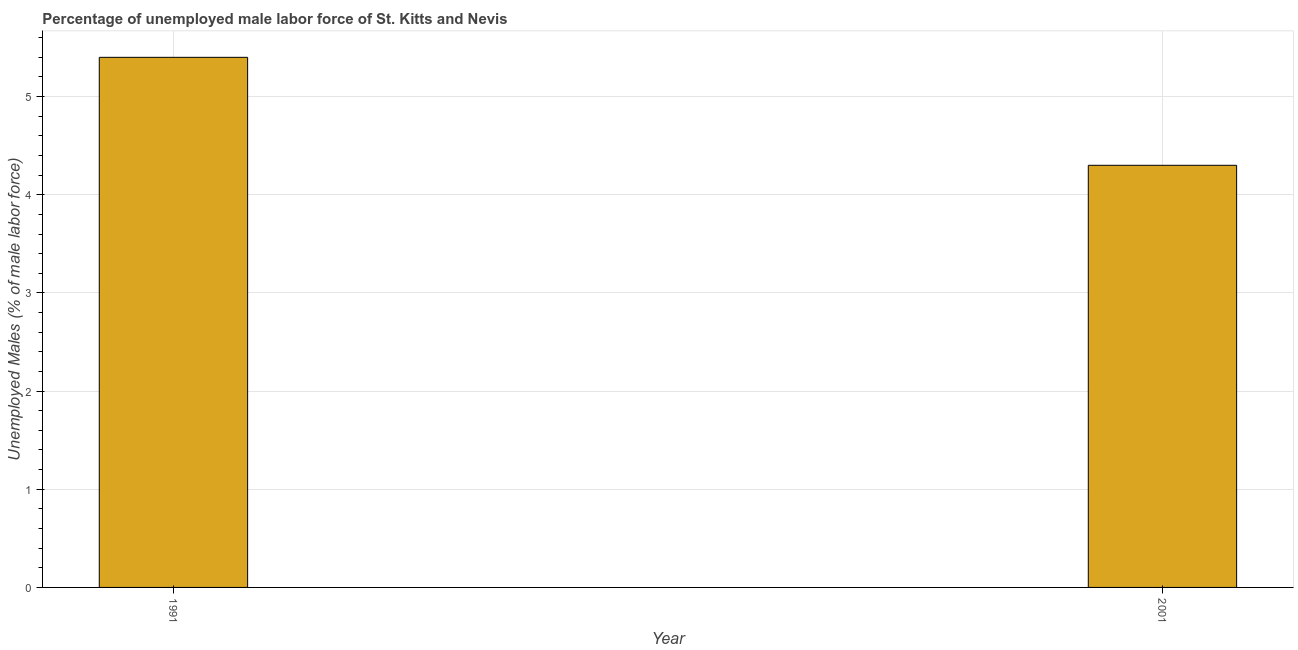Does the graph contain any zero values?
Provide a succinct answer. No. Does the graph contain grids?
Your answer should be very brief. Yes. What is the title of the graph?
Your answer should be compact. Percentage of unemployed male labor force of St. Kitts and Nevis. What is the label or title of the Y-axis?
Your response must be concise. Unemployed Males (% of male labor force). What is the total unemployed male labour force in 2001?
Give a very brief answer. 4.3. Across all years, what is the maximum total unemployed male labour force?
Ensure brevity in your answer.  5.4. Across all years, what is the minimum total unemployed male labour force?
Offer a terse response. 4.3. In which year was the total unemployed male labour force minimum?
Provide a short and direct response. 2001. What is the sum of the total unemployed male labour force?
Provide a short and direct response. 9.7. What is the average total unemployed male labour force per year?
Make the answer very short. 4.85. What is the median total unemployed male labour force?
Provide a succinct answer. 4.85. In how many years, is the total unemployed male labour force greater than 4.6 %?
Your answer should be compact. 1. What is the ratio of the total unemployed male labour force in 1991 to that in 2001?
Your answer should be compact. 1.26. Is the total unemployed male labour force in 1991 less than that in 2001?
Your answer should be very brief. No. How many bars are there?
Your answer should be very brief. 2. What is the difference between two consecutive major ticks on the Y-axis?
Your answer should be very brief. 1. What is the Unemployed Males (% of male labor force) of 1991?
Provide a short and direct response. 5.4. What is the Unemployed Males (% of male labor force) in 2001?
Offer a terse response. 4.3. What is the difference between the Unemployed Males (% of male labor force) in 1991 and 2001?
Ensure brevity in your answer.  1.1. What is the ratio of the Unemployed Males (% of male labor force) in 1991 to that in 2001?
Your answer should be very brief. 1.26. 